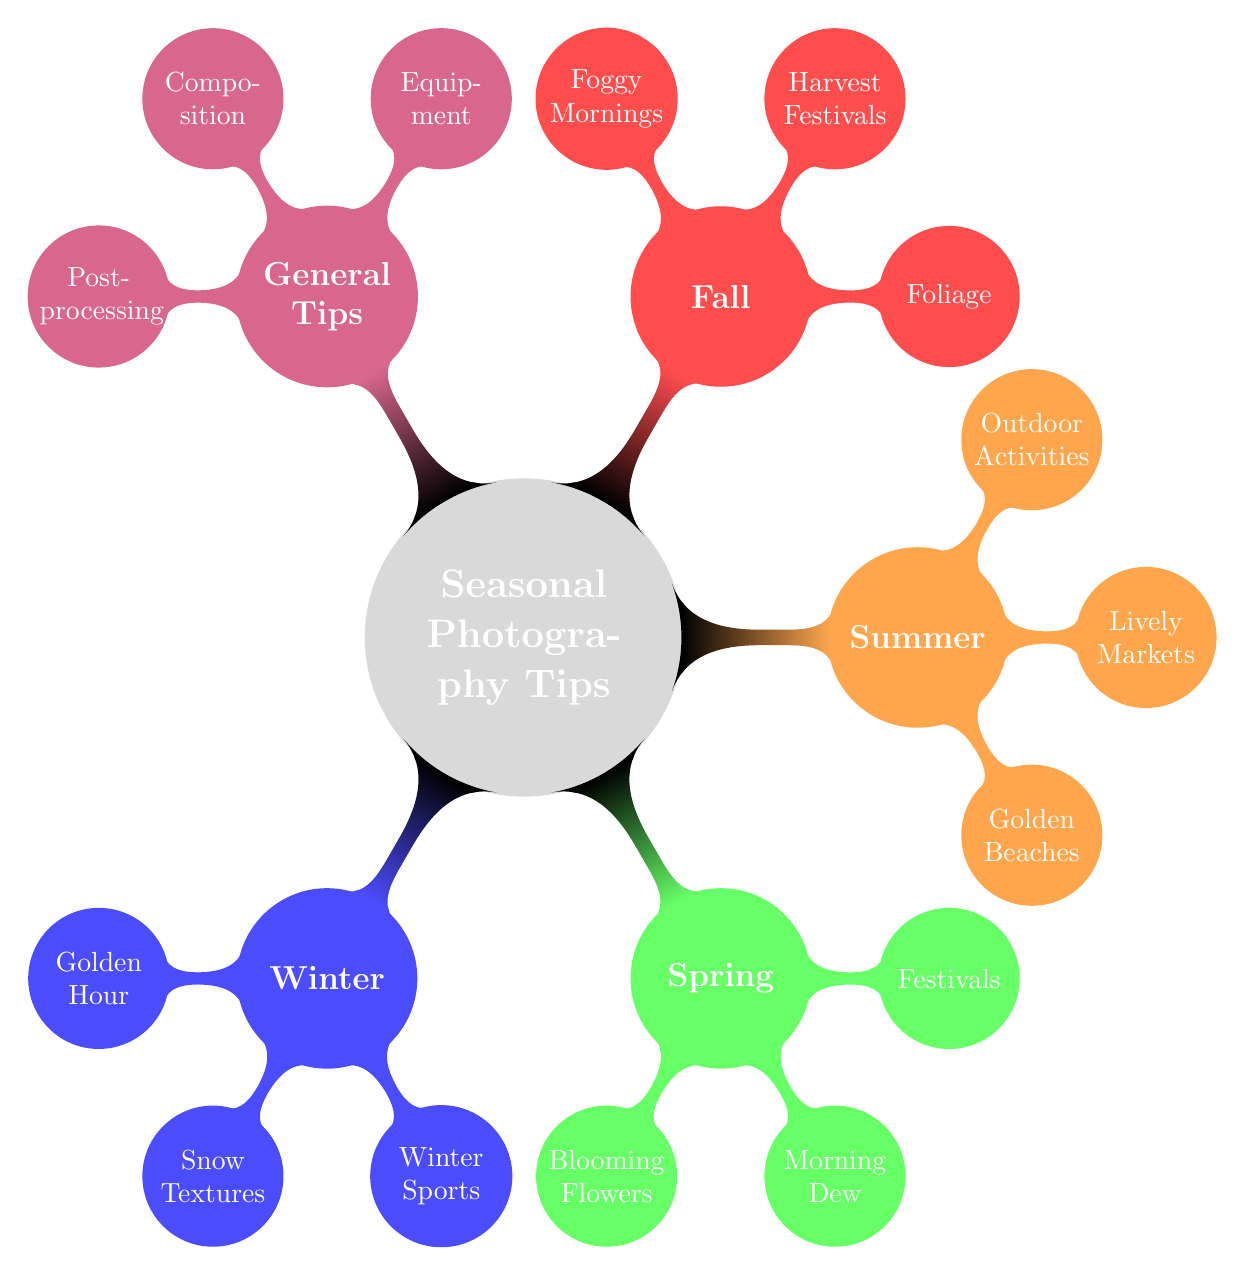What's the color associated with Winter in the diagram? The diagram specifies that Winter is represented by the concept color defined as "wintercolor", which is blue!70 in the color model.
Answer: blue!70 How many seasonal categories are present in the mind map? Counting the main branches in the diagram, we see there are four seasonal categories: Winter, Spring, Summer, and Fall, plus one general tips category.
Answer: 4 Which category contains "Foggy Mornings"? "Foggy Mornings" is listed as one of the sub-tips under the Fall season category, as shown in the diagram structure.
Answer: Fall What is one photography tip suggested for Spring? The Spring section has several tips, one of which is "Blooming Flowers", which falls under that seasonal category.
Answer: Blooming Flowers Which two seasonal categories focus on outdoor activities? The Summer and Winter categories both provide tips on outdoor activities, specifically "Outdoor Activities" and "Winter Sports" respectively.
Answer: Summer and Winter What is the main recommendation for equipment listed in the General Tips? In the General Tips category, the specific recommendation for equipment includes using "weather-resistant gear", which is essential for outdoor photography in different seasons.
Answer: weather-resistant gear How many tips are recommended under the Fall category? The diagram shows three tips under the Fall category: Foliage, Harvest Festivals, and Foggy Mornings, totaling that set to three.
Answer: 3 Name one location mentioned for capturing the "Golden Hour" in Winter. The mind map indicates Aspen, Colorado as a recommended location for capturing the "Golden Hour" during the Winter season.
Answer: Aspen, Colorado What compositional technique is suggested in the General Tips? The diagram lists "rule of thirds" as a recommended compositional technique to enhance the scenery in photography.
Answer: rule of thirds 